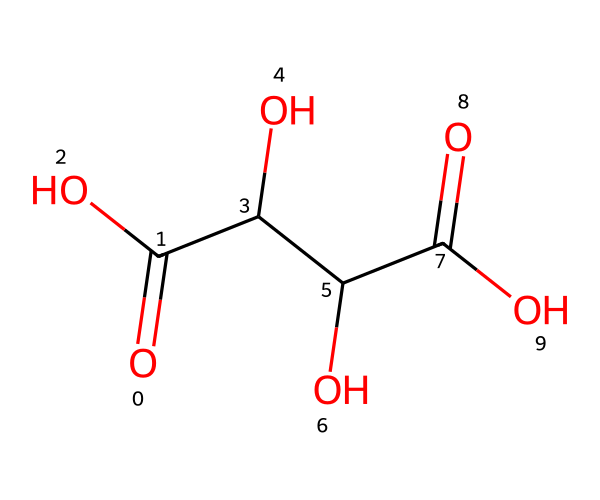What is the name of this acid? This chemical structure corresponds to tartaric acid, identifiable by its specific arrangement of carbon, hydrogen, and oxygen atoms.
Answer: tartaric acid How many hydroxyl groups are present? By examining the structure, there are three hydroxyl (-OH) groups, indicated by the presence of oxygen bonded to hydrogen in three locations.
Answer: 3 What is the total number of carbon atoms? The structure shows four carbon atoms, which can be counted directly from the central carbon frame of the molecule.
Answer: 4 What type of functional groups are present? The molecule contains carboxylic acid groups (-COOH) and hydroxyl groups (-OH), both of which are characteristic of tartaric acid.
Answer: carboxylic acid and hydroxyl groups What is the significance of the chiral centers in this molecule? The presence of two chiral centers in tartaric acid contributes to its optical activity, affecting how it interacts with polarized light and influencing its taste and biological activity.
Answer: optical activity What is the pH range of tartaric acid solutions? Tartaric acid solutions typically have a pH range of around 3 to 4, which is slightly acidic due to the released protons from its carboxylic groups.
Answer: 3 to 4 